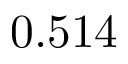<formula> <loc_0><loc_0><loc_500><loc_500>0 . 5 1 4</formula> 